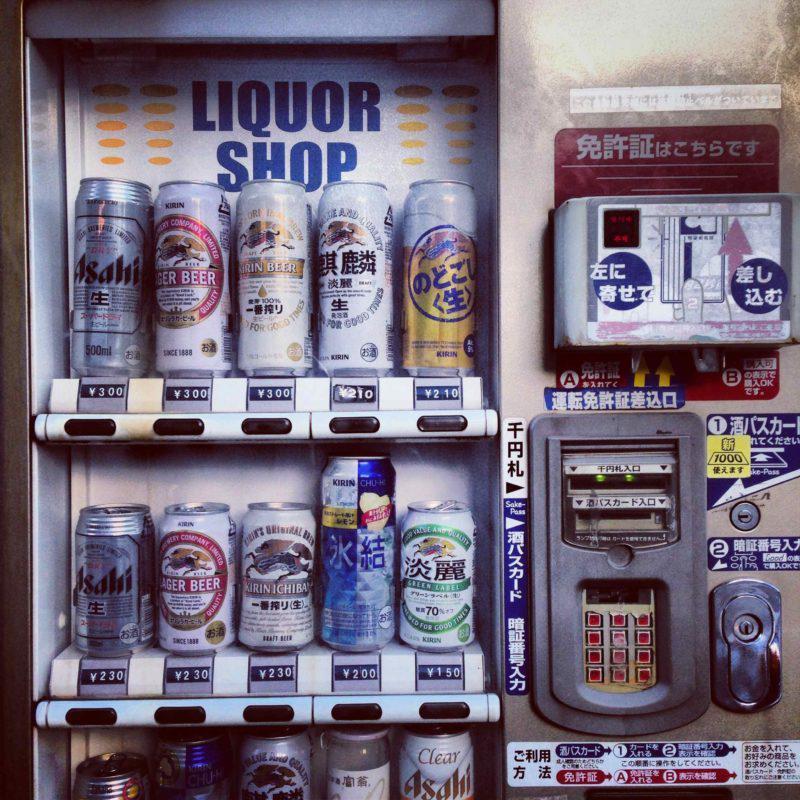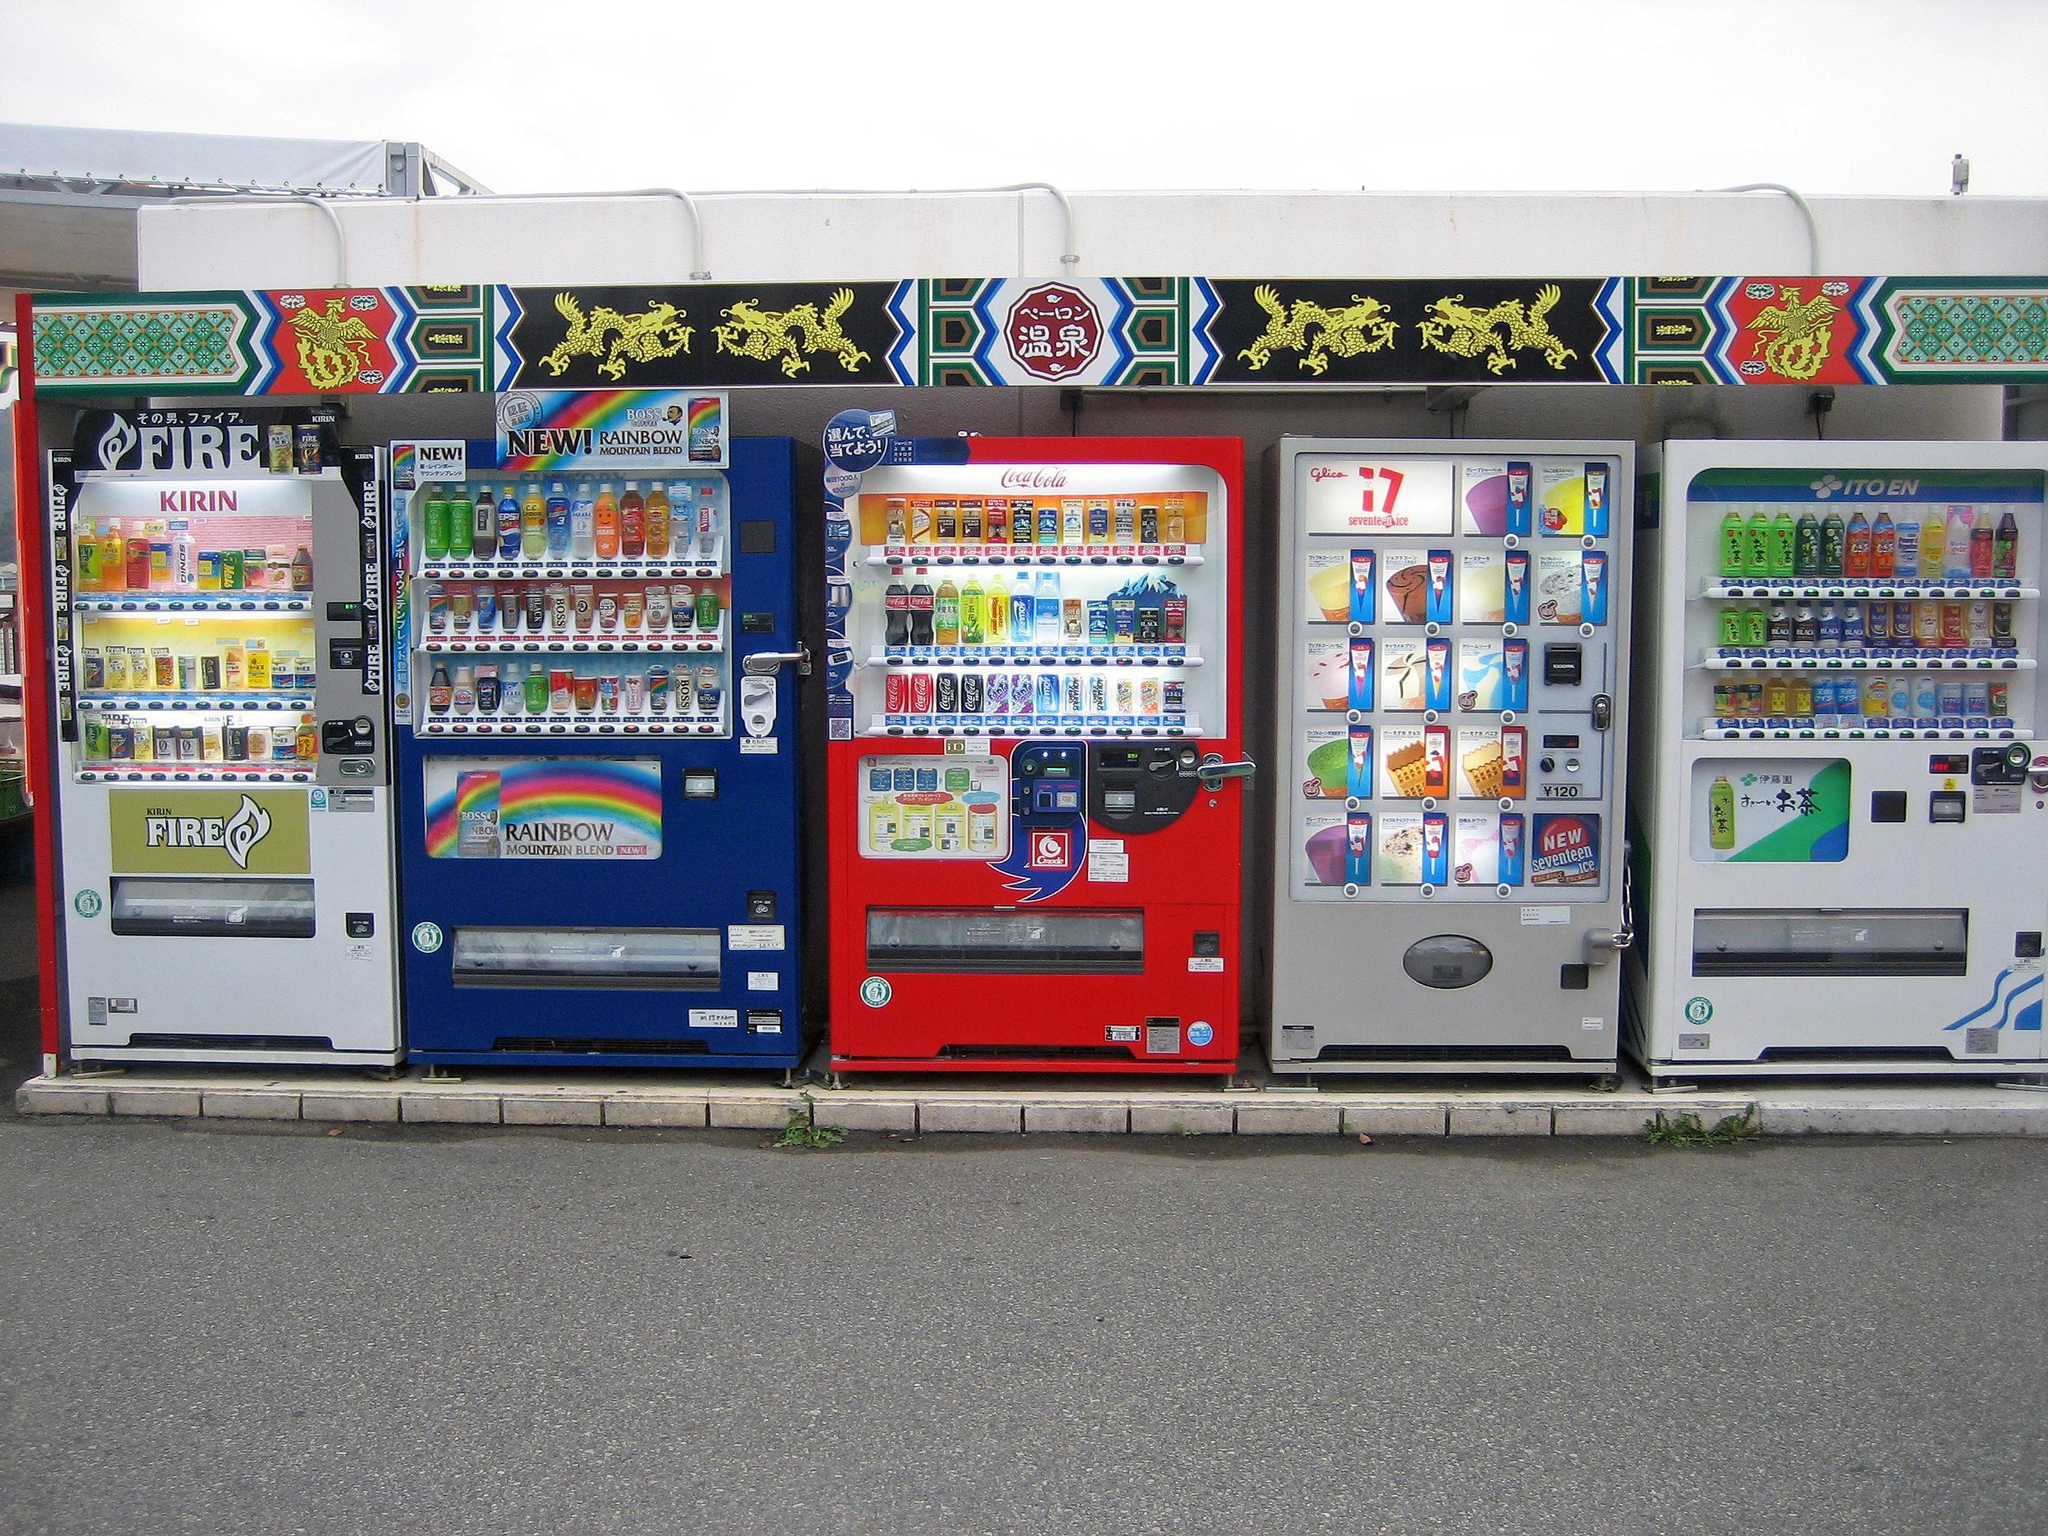The first image is the image on the left, the second image is the image on the right. Examine the images to the left and right. Is the description "In a row of at least five vending machines, one machine is gray." accurate? Answer yes or no. Yes. The first image is the image on the left, the second image is the image on the right. Given the left and right images, does the statement "One of the images shows a white vending machine that offers plates of food instead of beverages." hold true? Answer yes or no. No. 